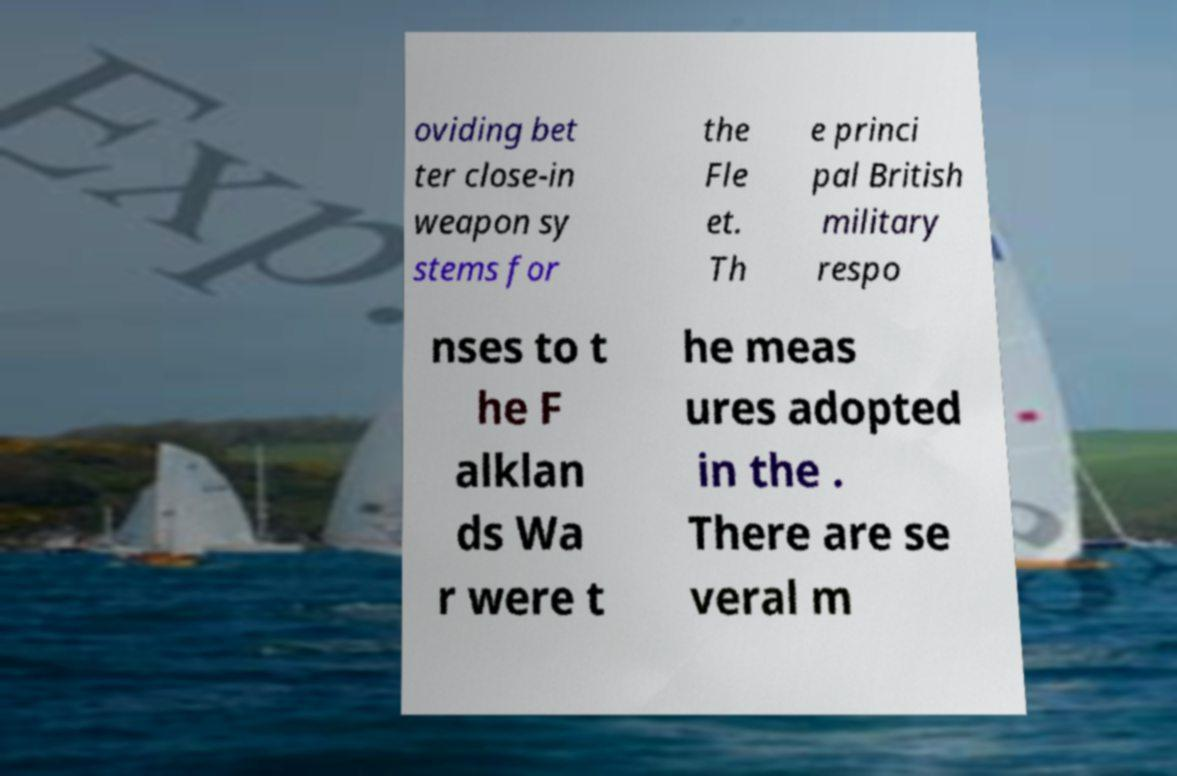What messages or text are displayed in this image? I need them in a readable, typed format. oviding bet ter close-in weapon sy stems for the Fle et. Th e princi pal British military respo nses to t he F alklan ds Wa r were t he meas ures adopted in the . There are se veral m 